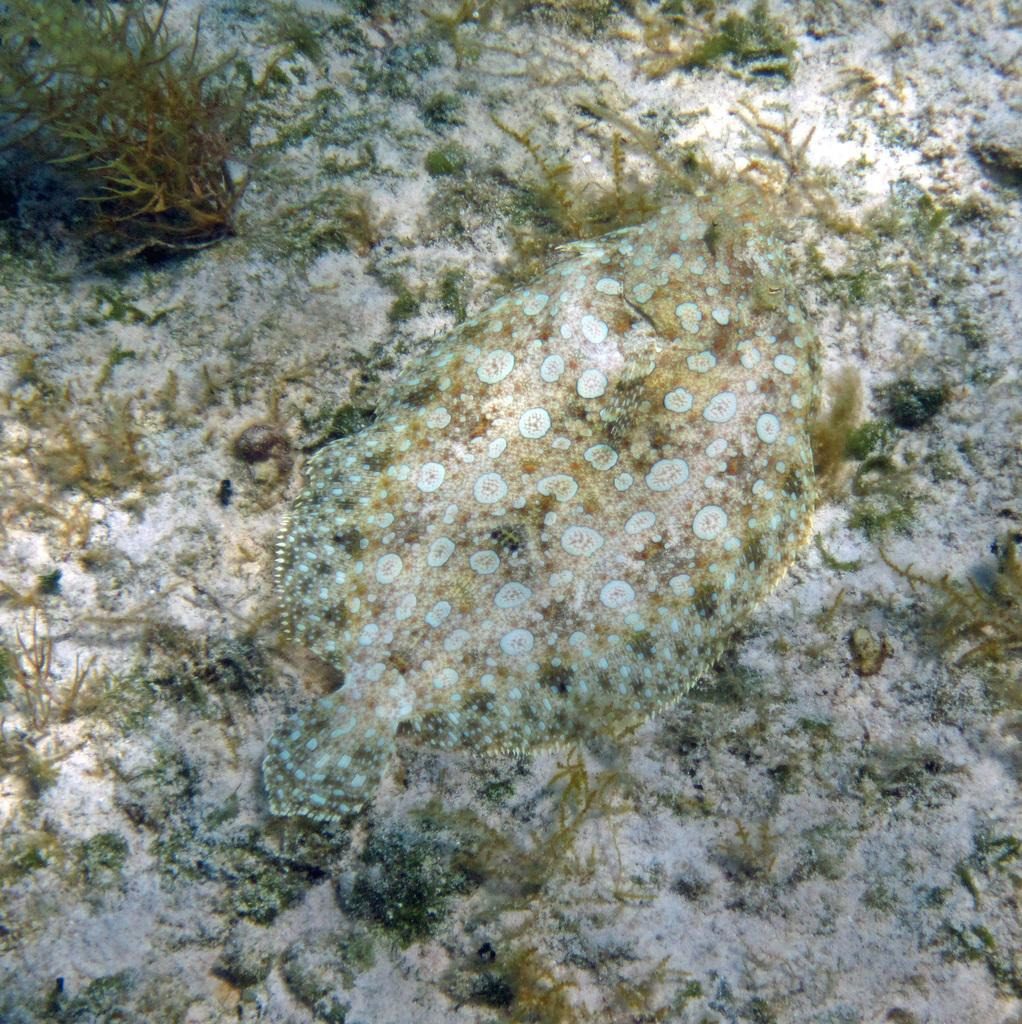What type of animal can be seen in the image? There is a sea animal in the image. What other elements are present in the image besides the sea animal? There are plants in the image. What type of government is depicted in the image? There is no depiction of a government in the image; it features a sea animal and plants. Is there any smoke visible in the image? There is no smoke present in the image. 